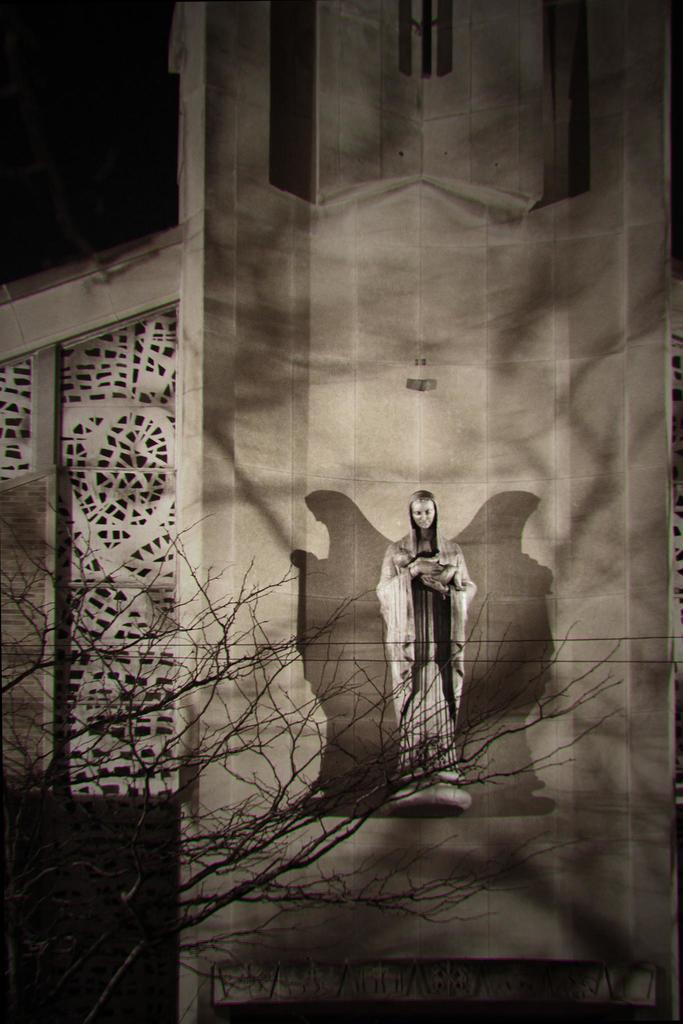What type of structure is visible in the image? There is a building in the image. What is attached to the building? A sculpture is attached to the building. What is the condition of the tree in front of the building? There is a dry tree in front of the building. What type of bait is used to catch fish in the image? There is no mention of fish or bait in the image; it features a building with a sculpture and a dry tree. 